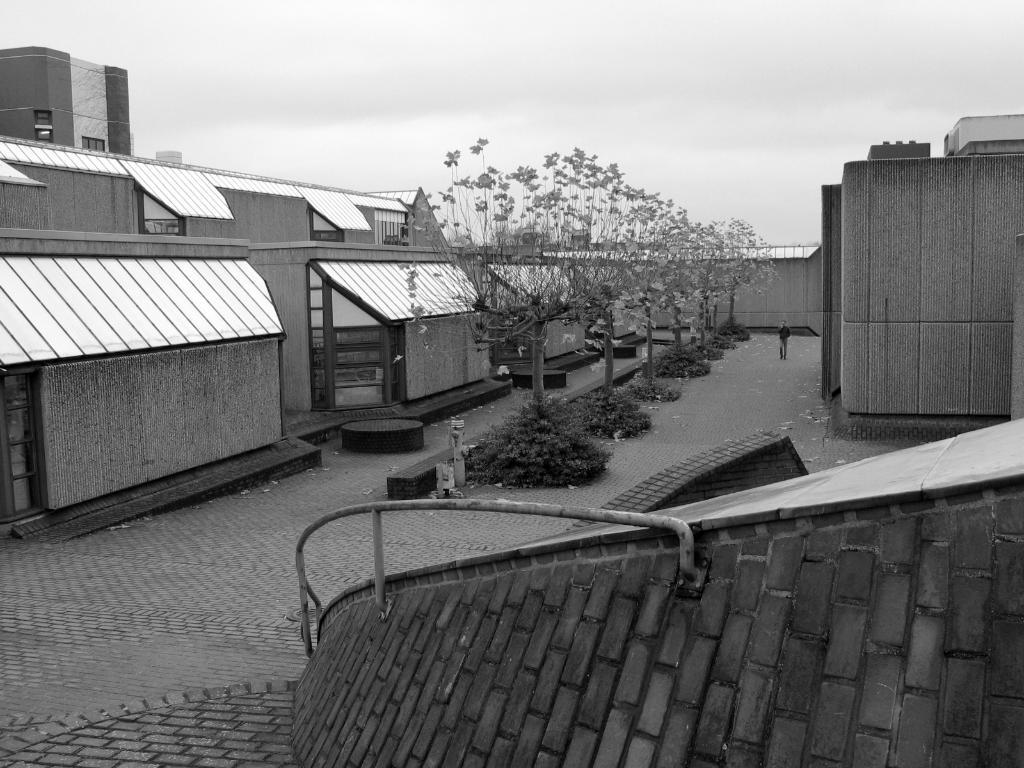What is located at the front of the image? There is a fence at the front of the image. What type of natural elements can be seen in the image? There are trees in the image. Can you describe the person in the image? There is a person present at the center of the image. What type of man-made structures are visible in the image? There are buildings in the image. What is the color scheme of the image? The image is black and white. What type of arch is present in the image? There is no arch present in the image. What event is taking place in the image? The image does not depict any specific event; it simply shows a fence, trees, a person, buildings, and is in black and white. 